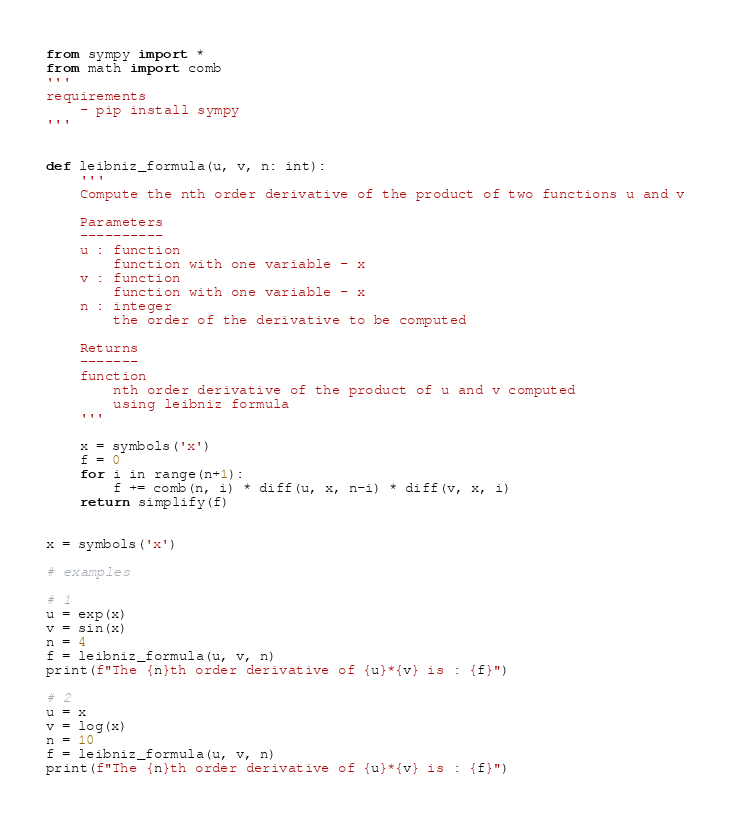<code> <loc_0><loc_0><loc_500><loc_500><_Python_>from sympy import *
from math import comb
'''
requirements 
    - pip install sympy
'''


def leibniz_formula(u, v, n: int):
    '''
    Compute the nth order derivative of the product of two functions u and v

    Parameters
    ----------
    u : function
        function with one variable - x
    v : function
        function with one variable - x
    n : integer
        the order of the derivative to be computed

    Returns
    -------
    function
        nth order derivative of the product of u and v computed 
        using leibniz formula
    '''

    x = symbols('x')
    f = 0
    for i in range(n+1):
        f += comb(n, i) * diff(u, x, n-i) * diff(v, x, i)
    return simplify(f)


x = symbols('x')

# examples

# 1
u = exp(x)
v = sin(x)
n = 4
f = leibniz_formula(u, v, n)
print(f"The {n}th order derivative of {u}*{v} is : {f}")

# 2
u = x
v = log(x)
n = 10
f = leibniz_formula(u, v, n)
print(f"The {n}th order derivative of {u}*{v} is : {f}")
</code> 